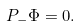Convert formula to latex. <formula><loc_0><loc_0><loc_500><loc_500>P _ { - } \Phi = 0 .</formula> 